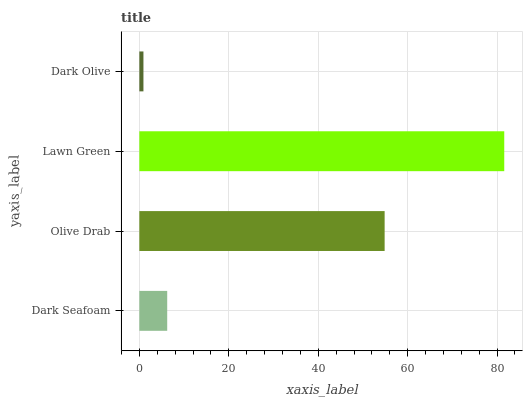Is Dark Olive the minimum?
Answer yes or no. Yes. Is Lawn Green the maximum?
Answer yes or no. Yes. Is Olive Drab the minimum?
Answer yes or no. No. Is Olive Drab the maximum?
Answer yes or no. No. Is Olive Drab greater than Dark Seafoam?
Answer yes or no. Yes. Is Dark Seafoam less than Olive Drab?
Answer yes or no. Yes. Is Dark Seafoam greater than Olive Drab?
Answer yes or no. No. Is Olive Drab less than Dark Seafoam?
Answer yes or no. No. Is Olive Drab the high median?
Answer yes or no. Yes. Is Dark Seafoam the low median?
Answer yes or no. Yes. Is Dark Seafoam the high median?
Answer yes or no. No. Is Lawn Green the low median?
Answer yes or no. No. 